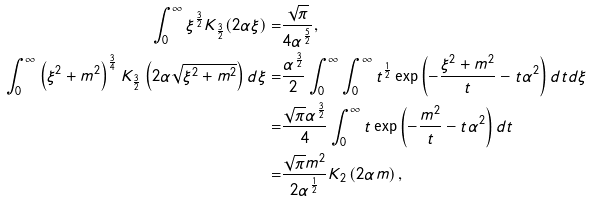<formula> <loc_0><loc_0><loc_500><loc_500>\int _ { 0 } ^ { \infty } \xi ^ { \frac { 3 } { 2 } } K _ { \frac { 3 } { 2 } } ( 2 \alpha \xi ) = & \frac { \sqrt { \pi } } { 4 \alpha ^ { \frac { 5 } { 2 } } } , \\ \int _ { 0 } ^ { \infty } \left ( \xi ^ { 2 } + m ^ { 2 } \right ) ^ { \frac { 3 } { 4 } } K _ { \frac { 3 } { 2 } } \left ( 2 \alpha \sqrt { \xi ^ { 2 } + m ^ { 2 } } \right ) d \xi = & \frac { \alpha ^ { \frac { 3 } { 2 } } } { 2 } \int _ { 0 } ^ { \infty } \int _ { 0 } ^ { \infty } t ^ { \frac { 1 } { 2 } } \exp \left ( - \frac { \xi ^ { 2 } + m ^ { 2 } } { t } - t \alpha ^ { 2 } \right ) d t d \xi \\ = & \frac { \sqrt { \pi } \alpha ^ { \frac { 3 } { 2 } } } { 4 } \int _ { 0 } ^ { \infty } t \exp \left ( - \frac { m ^ { 2 } } { t } - t \alpha ^ { 2 } \right ) d t \\ = & \frac { \sqrt { \pi } m ^ { 2 } } { 2 \alpha ^ { \frac { 1 } { 2 } } } K _ { 2 } \left ( 2 \alpha m \right ) ,</formula> 